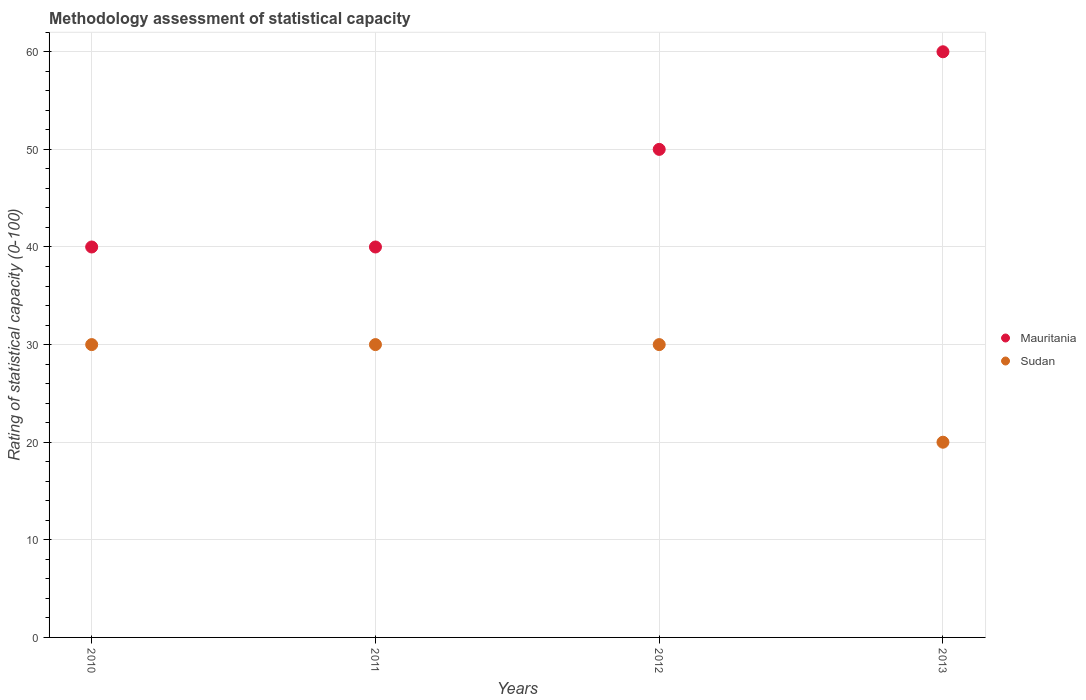How many different coloured dotlines are there?
Make the answer very short. 2. Is the number of dotlines equal to the number of legend labels?
Your answer should be compact. Yes. What is the rating of statistical capacity in Sudan in 2011?
Make the answer very short. 30. Across all years, what is the maximum rating of statistical capacity in Sudan?
Ensure brevity in your answer.  30. Across all years, what is the minimum rating of statistical capacity in Sudan?
Offer a terse response. 20. In which year was the rating of statistical capacity in Sudan minimum?
Provide a short and direct response. 2013. What is the total rating of statistical capacity in Sudan in the graph?
Your response must be concise. 110. What is the difference between the rating of statistical capacity in Sudan in 2011 and that in 2012?
Offer a terse response. 0. What is the difference between the rating of statistical capacity in Sudan in 2010 and the rating of statistical capacity in Mauritania in 2012?
Your answer should be compact. -20. What is the average rating of statistical capacity in Sudan per year?
Your response must be concise. 27.5. In the year 2010, what is the difference between the rating of statistical capacity in Mauritania and rating of statistical capacity in Sudan?
Your answer should be very brief. 10. What is the difference between the highest and the lowest rating of statistical capacity in Sudan?
Your answer should be very brief. 10. Is the sum of the rating of statistical capacity in Mauritania in 2011 and 2012 greater than the maximum rating of statistical capacity in Sudan across all years?
Ensure brevity in your answer.  Yes. Is the rating of statistical capacity in Sudan strictly greater than the rating of statistical capacity in Mauritania over the years?
Your response must be concise. No. Is the rating of statistical capacity in Sudan strictly less than the rating of statistical capacity in Mauritania over the years?
Give a very brief answer. Yes. How many dotlines are there?
Your response must be concise. 2. What is the difference between two consecutive major ticks on the Y-axis?
Make the answer very short. 10. Are the values on the major ticks of Y-axis written in scientific E-notation?
Give a very brief answer. No. Where does the legend appear in the graph?
Your answer should be very brief. Center right. How many legend labels are there?
Make the answer very short. 2. What is the title of the graph?
Give a very brief answer. Methodology assessment of statistical capacity. Does "Tunisia" appear as one of the legend labels in the graph?
Provide a succinct answer. No. What is the label or title of the X-axis?
Make the answer very short. Years. What is the label or title of the Y-axis?
Provide a succinct answer. Rating of statistical capacity (0-100). What is the Rating of statistical capacity (0-100) in Mauritania in 2010?
Provide a short and direct response. 40. What is the Rating of statistical capacity (0-100) in Sudan in 2010?
Ensure brevity in your answer.  30. What is the Rating of statistical capacity (0-100) of Mauritania in 2011?
Offer a very short reply. 40. What is the Rating of statistical capacity (0-100) of Mauritania in 2012?
Make the answer very short. 50. What is the Rating of statistical capacity (0-100) in Mauritania in 2013?
Keep it short and to the point. 60. What is the Rating of statistical capacity (0-100) in Sudan in 2013?
Ensure brevity in your answer.  20. Across all years, what is the maximum Rating of statistical capacity (0-100) in Mauritania?
Your response must be concise. 60. Across all years, what is the maximum Rating of statistical capacity (0-100) in Sudan?
Your answer should be very brief. 30. Across all years, what is the minimum Rating of statistical capacity (0-100) of Mauritania?
Your response must be concise. 40. What is the total Rating of statistical capacity (0-100) of Mauritania in the graph?
Offer a very short reply. 190. What is the total Rating of statistical capacity (0-100) in Sudan in the graph?
Ensure brevity in your answer.  110. What is the difference between the Rating of statistical capacity (0-100) in Mauritania in 2010 and that in 2012?
Your answer should be very brief. -10. What is the difference between the Rating of statistical capacity (0-100) in Sudan in 2010 and that in 2012?
Ensure brevity in your answer.  0. What is the difference between the Rating of statistical capacity (0-100) of Sudan in 2010 and that in 2013?
Offer a very short reply. 10. What is the difference between the Rating of statistical capacity (0-100) of Mauritania in 2011 and that in 2012?
Your response must be concise. -10. What is the difference between the Rating of statistical capacity (0-100) in Sudan in 2011 and that in 2013?
Your answer should be compact. 10. What is the difference between the Rating of statistical capacity (0-100) in Sudan in 2012 and that in 2013?
Provide a short and direct response. 10. What is the difference between the Rating of statistical capacity (0-100) of Mauritania in 2010 and the Rating of statistical capacity (0-100) of Sudan in 2011?
Your response must be concise. 10. What is the difference between the Rating of statistical capacity (0-100) of Mauritania in 2010 and the Rating of statistical capacity (0-100) of Sudan in 2012?
Make the answer very short. 10. What is the average Rating of statistical capacity (0-100) of Mauritania per year?
Provide a succinct answer. 47.5. In the year 2010, what is the difference between the Rating of statistical capacity (0-100) of Mauritania and Rating of statistical capacity (0-100) of Sudan?
Provide a succinct answer. 10. In the year 2011, what is the difference between the Rating of statistical capacity (0-100) of Mauritania and Rating of statistical capacity (0-100) of Sudan?
Offer a terse response. 10. What is the ratio of the Rating of statistical capacity (0-100) in Sudan in 2010 to that in 2013?
Provide a short and direct response. 1.5. What is the ratio of the Rating of statistical capacity (0-100) of Sudan in 2011 to that in 2012?
Provide a succinct answer. 1. What is the difference between the highest and the second highest Rating of statistical capacity (0-100) of Sudan?
Make the answer very short. 0. What is the difference between the highest and the lowest Rating of statistical capacity (0-100) in Mauritania?
Give a very brief answer. 20. 